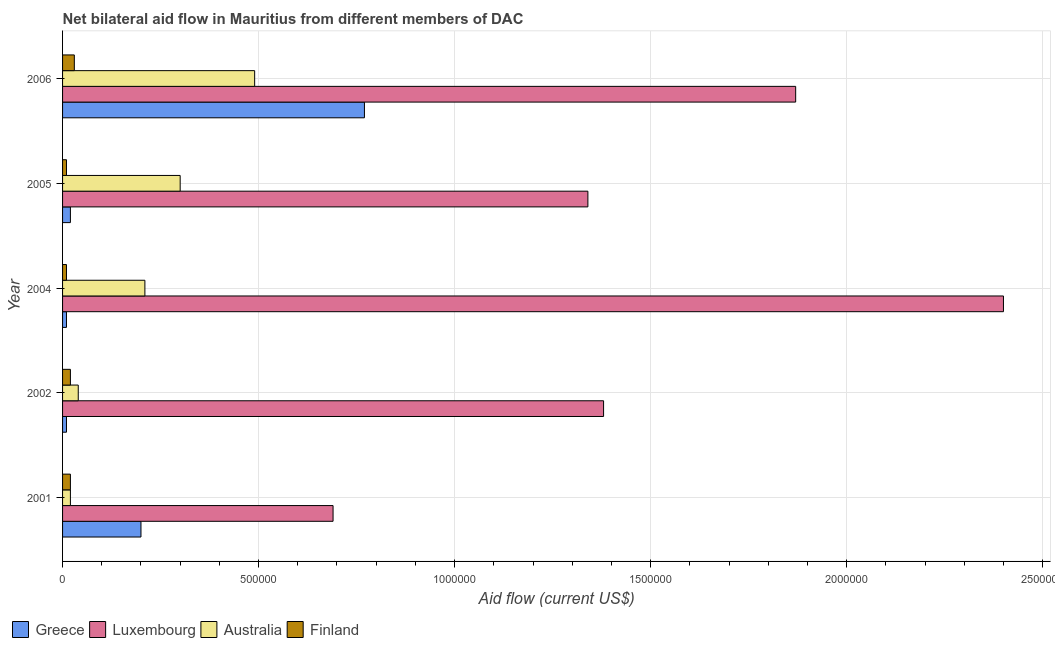Are the number of bars per tick equal to the number of legend labels?
Make the answer very short. Yes. Are the number of bars on each tick of the Y-axis equal?
Make the answer very short. Yes. What is the label of the 5th group of bars from the top?
Keep it short and to the point. 2001. What is the amount of aid given by australia in 2006?
Keep it short and to the point. 4.90e+05. Across all years, what is the maximum amount of aid given by australia?
Your answer should be very brief. 4.90e+05. Across all years, what is the minimum amount of aid given by finland?
Your answer should be very brief. 10000. In which year was the amount of aid given by australia maximum?
Your answer should be very brief. 2006. What is the total amount of aid given by finland in the graph?
Your response must be concise. 9.00e+04. What is the difference between the amount of aid given by greece in 2004 and that in 2005?
Provide a succinct answer. -10000. What is the difference between the amount of aid given by greece in 2005 and the amount of aid given by australia in 2001?
Provide a succinct answer. 0. What is the average amount of aid given by greece per year?
Provide a short and direct response. 2.02e+05. In the year 2005, what is the difference between the amount of aid given by greece and amount of aid given by australia?
Ensure brevity in your answer.  -2.80e+05. In how many years, is the amount of aid given by greece greater than 1500000 US$?
Make the answer very short. 0. Is the difference between the amount of aid given by finland in 2002 and 2006 greater than the difference between the amount of aid given by greece in 2002 and 2006?
Ensure brevity in your answer.  Yes. What is the difference between the highest and the second highest amount of aid given by greece?
Offer a terse response. 5.70e+05. What is the difference between the highest and the lowest amount of aid given by greece?
Give a very brief answer. 7.60e+05. In how many years, is the amount of aid given by finland greater than the average amount of aid given by finland taken over all years?
Keep it short and to the point. 3. What does the 1st bar from the bottom in 2002 represents?
Give a very brief answer. Greece. How many years are there in the graph?
Keep it short and to the point. 5. What is the difference between two consecutive major ticks on the X-axis?
Offer a very short reply. 5.00e+05. Are the values on the major ticks of X-axis written in scientific E-notation?
Your response must be concise. No. How are the legend labels stacked?
Keep it short and to the point. Horizontal. What is the title of the graph?
Provide a short and direct response. Net bilateral aid flow in Mauritius from different members of DAC. Does "Tracking ability" appear as one of the legend labels in the graph?
Provide a short and direct response. No. What is the label or title of the Y-axis?
Provide a succinct answer. Year. What is the Aid flow (current US$) in Luxembourg in 2001?
Make the answer very short. 6.90e+05. What is the Aid flow (current US$) of Australia in 2001?
Your response must be concise. 2.00e+04. What is the Aid flow (current US$) of Greece in 2002?
Provide a succinct answer. 10000. What is the Aid flow (current US$) of Luxembourg in 2002?
Offer a terse response. 1.38e+06. What is the Aid flow (current US$) in Australia in 2002?
Keep it short and to the point. 4.00e+04. What is the Aid flow (current US$) in Finland in 2002?
Offer a very short reply. 2.00e+04. What is the Aid flow (current US$) in Greece in 2004?
Your answer should be compact. 10000. What is the Aid flow (current US$) of Luxembourg in 2004?
Offer a very short reply. 2.40e+06. What is the Aid flow (current US$) of Finland in 2004?
Provide a short and direct response. 10000. What is the Aid flow (current US$) in Luxembourg in 2005?
Offer a terse response. 1.34e+06. What is the Aid flow (current US$) in Greece in 2006?
Provide a short and direct response. 7.70e+05. What is the Aid flow (current US$) of Luxembourg in 2006?
Provide a short and direct response. 1.87e+06. What is the Aid flow (current US$) in Australia in 2006?
Keep it short and to the point. 4.90e+05. Across all years, what is the maximum Aid flow (current US$) in Greece?
Your answer should be compact. 7.70e+05. Across all years, what is the maximum Aid flow (current US$) of Luxembourg?
Your answer should be very brief. 2.40e+06. Across all years, what is the maximum Aid flow (current US$) of Australia?
Provide a short and direct response. 4.90e+05. Across all years, what is the minimum Aid flow (current US$) of Greece?
Make the answer very short. 10000. Across all years, what is the minimum Aid flow (current US$) of Luxembourg?
Give a very brief answer. 6.90e+05. What is the total Aid flow (current US$) of Greece in the graph?
Make the answer very short. 1.01e+06. What is the total Aid flow (current US$) of Luxembourg in the graph?
Make the answer very short. 7.68e+06. What is the total Aid flow (current US$) in Australia in the graph?
Make the answer very short. 1.06e+06. What is the total Aid flow (current US$) of Finland in the graph?
Make the answer very short. 9.00e+04. What is the difference between the Aid flow (current US$) of Luxembourg in 2001 and that in 2002?
Keep it short and to the point. -6.90e+05. What is the difference between the Aid flow (current US$) of Luxembourg in 2001 and that in 2004?
Your response must be concise. -1.71e+06. What is the difference between the Aid flow (current US$) in Australia in 2001 and that in 2004?
Your answer should be very brief. -1.90e+05. What is the difference between the Aid flow (current US$) in Greece in 2001 and that in 2005?
Ensure brevity in your answer.  1.80e+05. What is the difference between the Aid flow (current US$) in Luxembourg in 2001 and that in 2005?
Make the answer very short. -6.50e+05. What is the difference between the Aid flow (current US$) of Australia in 2001 and that in 2005?
Keep it short and to the point. -2.80e+05. What is the difference between the Aid flow (current US$) in Finland in 2001 and that in 2005?
Your answer should be compact. 10000. What is the difference between the Aid flow (current US$) of Greece in 2001 and that in 2006?
Offer a terse response. -5.70e+05. What is the difference between the Aid flow (current US$) in Luxembourg in 2001 and that in 2006?
Provide a short and direct response. -1.18e+06. What is the difference between the Aid flow (current US$) in Australia in 2001 and that in 2006?
Provide a succinct answer. -4.70e+05. What is the difference between the Aid flow (current US$) in Finland in 2001 and that in 2006?
Your answer should be compact. -10000. What is the difference between the Aid flow (current US$) in Greece in 2002 and that in 2004?
Your answer should be very brief. 0. What is the difference between the Aid flow (current US$) of Luxembourg in 2002 and that in 2004?
Your answer should be very brief. -1.02e+06. What is the difference between the Aid flow (current US$) in Luxembourg in 2002 and that in 2005?
Your answer should be very brief. 4.00e+04. What is the difference between the Aid flow (current US$) of Greece in 2002 and that in 2006?
Your response must be concise. -7.60e+05. What is the difference between the Aid flow (current US$) in Luxembourg in 2002 and that in 2006?
Provide a succinct answer. -4.90e+05. What is the difference between the Aid flow (current US$) in Australia in 2002 and that in 2006?
Your answer should be very brief. -4.50e+05. What is the difference between the Aid flow (current US$) of Greece in 2004 and that in 2005?
Your response must be concise. -10000. What is the difference between the Aid flow (current US$) of Luxembourg in 2004 and that in 2005?
Your response must be concise. 1.06e+06. What is the difference between the Aid flow (current US$) in Australia in 2004 and that in 2005?
Ensure brevity in your answer.  -9.00e+04. What is the difference between the Aid flow (current US$) of Greece in 2004 and that in 2006?
Your answer should be very brief. -7.60e+05. What is the difference between the Aid flow (current US$) of Luxembourg in 2004 and that in 2006?
Your answer should be compact. 5.30e+05. What is the difference between the Aid flow (current US$) of Australia in 2004 and that in 2006?
Keep it short and to the point. -2.80e+05. What is the difference between the Aid flow (current US$) in Greece in 2005 and that in 2006?
Ensure brevity in your answer.  -7.50e+05. What is the difference between the Aid flow (current US$) in Luxembourg in 2005 and that in 2006?
Your answer should be very brief. -5.30e+05. What is the difference between the Aid flow (current US$) of Greece in 2001 and the Aid flow (current US$) of Luxembourg in 2002?
Keep it short and to the point. -1.18e+06. What is the difference between the Aid flow (current US$) in Greece in 2001 and the Aid flow (current US$) in Australia in 2002?
Give a very brief answer. 1.60e+05. What is the difference between the Aid flow (current US$) in Greece in 2001 and the Aid flow (current US$) in Finland in 2002?
Your response must be concise. 1.80e+05. What is the difference between the Aid flow (current US$) in Luxembourg in 2001 and the Aid flow (current US$) in Australia in 2002?
Your answer should be very brief. 6.50e+05. What is the difference between the Aid flow (current US$) in Luxembourg in 2001 and the Aid flow (current US$) in Finland in 2002?
Offer a very short reply. 6.70e+05. What is the difference between the Aid flow (current US$) of Greece in 2001 and the Aid flow (current US$) of Luxembourg in 2004?
Your answer should be compact. -2.20e+06. What is the difference between the Aid flow (current US$) in Greece in 2001 and the Aid flow (current US$) in Australia in 2004?
Your answer should be very brief. -10000. What is the difference between the Aid flow (current US$) of Greece in 2001 and the Aid flow (current US$) of Finland in 2004?
Give a very brief answer. 1.90e+05. What is the difference between the Aid flow (current US$) in Luxembourg in 2001 and the Aid flow (current US$) in Finland in 2004?
Offer a very short reply. 6.80e+05. What is the difference between the Aid flow (current US$) of Greece in 2001 and the Aid flow (current US$) of Luxembourg in 2005?
Your response must be concise. -1.14e+06. What is the difference between the Aid flow (current US$) in Luxembourg in 2001 and the Aid flow (current US$) in Finland in 2005?
Your answer should be very brief. 6.80e+05. What is the difference between the Aid flow (current US$) in Greece in 2001 and the Aid flow (current US$) in Luxembourg in 2006?
Provide a succinct answer. -1.67e+06. What is the difference between the Aid flow (current US$) in Greece in 2001 and the Aid flow (current US$) in Finland in 2006?
Your response must be concise. 1.70e+05. What is the difference between the Aid flow (current US$) in Luxembourg in 2001 and the Aid flow (current US$) in Australia in 2006?
Your answer should be compact. 2.00e+05. What is the difference between the Aid flow (current US$) in Luxembourg in 2001 and the Aid flow (current US$) in Finland in 2006?
Make the answer very short. 6.60e+05. What is the difference between the Aid flow (current US$) of Australia in 2001 and the Aid flow (current US$) of Finland in 2006?
Provide a short and direct response. -10000. What is the difference between the Aid flow (current US$) in Greece in 2002 and the Aid flow (current US$) in Luxembourg in 2004?
Make the answer very short. -2.39e+06. What is the difference between the Aid flow (current US$) in Greece in 2002 and the Aid flow (current US$) in Australia in 2004?
Keep it short and to the point. -2.00e+05. What is the difference between the Aid flow (current US$) of Luxembourg in 2002 and the Aid flow (current US$) of Australia in 2004?
Provide a succinct answer. 1.17e+06. What is the difference between the Aid flow (current US$) in Luxembourg in 2002 and the Aid flow (current US$) in Finland in 2004?
Offer a very short reply. 1.37e+06. What is the difference between the Aid flow (current US$) in Australia in 2002 and the Aid flow (current US$) in Finland in 2004?
Your answer should be very brief. 3.00e+04. What is the difference between the Aid flow (current US$) in Greece in 2002 and the Aid flow (current US$) in Luxembourg in 2005?
Offer a very short reply. -1.33e+06. What is the difference between the Aid flow (current US$) in Greece in 2002 and the Aid flow (current US$) in Australia in 2005?
Make the answer very short. -2.90e+05. What is the difference between the Aid flow (current US$) in Luxembourg in 2002 and the Aid flow (current US$) in Australia in 2005?
Make the answer very short. 1.08e+06. What is the difference between the Aid flow (current US$) in Luxembourg in 2002 and the Aid flow (current US$) in Finland in 2005?
Provide a short and direct response. 1.37e+06. What is the difference between the Aid flow (current US$) of Greece in 2002 and the Aid flow (current US$) of Luxembourg in 2006?
Offer a terse response. -1.86e+06. What is the difference between the Aid flow (current US$) of Greece in 2002 and the Aid flow (current US$) of Australia in 2006?
Your response must be concise. -4.80e+05. What is the difference between the Aid flow (current US$) in Luxembourg in 2002 and the Aid flow (current US$) in Australia in 2006?
Your answer should be very brief. 8.90e+05. What is the difference between the Aid flow (current US$) of Luxembourg in 2002 and the Aid flow (current US$) of Finland in 2006?
Provide a succinct answer. 1.35e+06. What is the difference between the Aid flow (current US$) of Greece in 2004 and the Aid flow (current US$) of Luxembourg in 2005?
Provide a short and direct response. -1.33e+06. What is the difference between the Aid flow (current US$) of Greece in 2004 and the Aid flow (current US$) of Australia in 2005?
Your answer should be very brief. -2.90e+05. What is the difference between the Aid flow (current US$) of Greece in 2004 and the Aid flow (current US$) of Finland in 2005?
Ensure brevity in your answer.  0. What is the difference between the Aid flow (current US$) of Luxembourg in 2004 and the Aid flow (current US$) of Australia in 2005?
Keep it short and to the point. 2.10e+06. What is the difference between the Aid flow (current US$) in Luxembourg in 2004 and the Aid flow (current US$) in Finland in 2005?
Your response must be concise. 2.39e+06. What is the difference between the Aid flow (current US$) in Australia in 2004 and the Aid flow (current US$) in Finland in 2005?
Ensure brevity in your answer.  2.00e+05. What is the difference between the Aid flow (current US$) of Greece in 2004 and the Aid flow (current US$) of Luxembourg in 2006?
Provide a succinct answer. -1.86e+06. What is the difference between the Aid flow (current US$) in Greece in 2004 and the Aid flow (current US$) in Australia in 2006?
Make the answer very short. -4.80e+05. What is the difference between the Aid flow (current US$) of Greece in 2004 and the Aid flow (current US$) of Finland in 2006?
Make the answer very short. -2.00e+04. What is the difference between the Aid flow (current US$) of Luxembourg in 2004 and the Aid flow (current US$) of Australia in 2006?
Make the answer very short. 1.91e+06. What is the difference between the Aid flow (current US$) of Luxembourg in 2004 and the Aid flow (current US$) of Finland in 2006?
Your answer should be very brief. 2.37e+06. What is the difference between the Aid flow (current US$) of Australia in 2004 and the Aid flow (current US$) of Finland in 2006?
Give a very brief answer. 1.80e+05. What is the difference between the Aid flow (current US$) in Greece in 2005 and the Aid flow (current US$) in Luxembourg in 2006?
Give a very brief answer. -1.85e+06. What is the difference between the Aid flow (current US$) in Greece in 2005 and the Aid flow (current US$) in Australia in 2006?
Ensure brevity in your answer.  -4.70e+05. What is the difference between the Aid flow (current US$) of Luxembourg in 2005 and the Aid flow (current US$) of Australia in 2006?
Give a very brief answer. 8.50e+05. What is the difference between the Aid flow (current US$) of Luxembourg in 2005 and the Aid flow (current US$) of Finland in 2006?
Your response must be concise. 1.31e+06. What is the average Aid flow (current US$) of Greece per year?
Keep it short and to the point. 2.02e+05. What is the average Aid flow (current US$) of Luxembourg per year?
Your response must be concise. 1.54e+06. What is the average Aid flow (current US$) in Australia per year?
Ensure brevity in your answer.  2.12e+05. What is the average Aid flow (current US$) in Finland per year?
Provide a short and direct response. 1.80e+04. In the year 2001, what is the difference between the Aid flow (current US$) in Greece and Aid flow (current US$) in Luxembourg?
Offer a very short reply. -4.90e+05. In the year 2001, what is the difference between the Aid flow (current US$) in Greece and Aid flow (current US$) in Finland?
Your response must be concise. 1.80e+05. In the year 2001, what is the difference between the Aid flow (current US$) of Luxembourg and Aid flow (current US$) of Australia?
Make the answer very short. 6.70e+05. In the year 2001, what is the difference between the Aid flow (current US$) of Luxembourg and Aid flow (current US$) of Finland?
Make the answer very short. 6.70e+05. In the year 2001, what is the difference between the Aid flow (current US$) in Australia and Aid flow (current US$) in Finland?
Your response must be concise. 0. In the year 2002, what is the difference between the Aid flow (current US$) in Greece and Aid flow (current US$) in Luxembourg?
Provide a short and direct response. -1.37e+06. In the year 2002, what is the difference between the Aid flow (current US$) of Greece and Aid flow (current US$) of Australia?
Offer a very short reply. -3.00e+04. In the year 2002, what is the difference between the Aid flow (current US$) of Luxembourg and Aid flow (current US$) of Australia?
Provide a short and direct response. 1.34e+06. In the year 2002, what is the difference between the Aid flow (current US$) in Luxembourg and Aid flow (current US$) in Finland?
Offer a terse response. 1.36e+06. In the year 2004, what is the difference between the Aid flow (current US$) of Greece and Aid flow (current US$) of Luxembourg?
Keep it short and to the point. -2.39e+06. In the year 2004, what is the difference between the Aid flow (current US$) in Greece and Aid flow (current US$) in Finland?
Give a very brief answer. 0. In the year 2004, what is the difference between the Aid flow (current US$) in Luxembourg and Aid flow (current US$) in Australia?
Provide a short and direct response. 2.19e+06. In the year 2004, what is the difference between the Aid flow (current US$) of Luxembourg and Aid flow (current US$) of Finland?
Your answer should be compact. 2.39e+06. In the year 2004, what is the difference between the Aid flow (current US$) in Australia and Aid flow (current US$) in Finland?
Your answer should be very brief. 2.00e+05. In the year 2005, what is the difference between the Aid flow (current US$) of Greece and Aid flow (current US$) of Luxembourg?
Make the answer very short. -1.32e+06. In the year 2005, what is the difference between the Aid flow (current US$) in Greece and Aid flow (current US$) in Australia?
Offer a terse response. -2.80e+05. In the year 2005, what is the difference between the Aid flow (current US$) of Greece and Aid flow (current US$) of Finland?
Keep it short and to the point. 10000. In the year 2005, what is the difference between the Aid flow (current US$) of Luxembourg and Aid flow (current US$) of Australia?
Your response must be concise. 1.04e+06. In the year 2005, what is the difference between the Aid flow (current US$) of Luxembourg and Aid flow (current US$) of Finland?
Your answer should be compact. 1.33e+06. In the year 2006, what is the difference between the Aid flow (current US$) in Greece and Aid flow (current US$) in Luxembourg?
Give a very brief answer. -1.10e+06. In the year 2006, what is the difference between the Aid flow (current US$) in Greece and Aid flow (current US$) in Finland?
Provide a succinct answer. 7.40e+05. In the year 2006, what is the difference between the Aid flow (current US$) in Luxembourg and Aid flow (current US$) in Australia?
Give a very brief answer. 1.38e+06. In the year 2006, what is the difference between the Aid flow (current US$) in Luxembourg and Aid flow (current US$) in Finland?
Give a very brief answer. 1.84e+06. In the year 2006, what is the difference between the Aid flow (current US$) in Australia and Aid flow (current US$) in Finland?
Ensure brevity in your answer.  4.60e+05. What is the ratio of the Aid flow (current US$) in Finland in 2001 to that in 2002?
Offer a very short reply. 1. What is the ratio of the Aid flow (current US$) of Luxembourg in 2001 to that in 2004?
Offer a terse response. 0.29. What is the ratio of the Aid flow (current US$) of Australia in 2001 to that in 2004?
Your answer should be very brief. 0.1. What is the ratio of the Aid flow (current US$) in Luxembourg in 2001 to that in 2005?
Make the answer very short. 0.51. What is the ratio of the Aid flow (current US$) of Australia in 2001 to that in 2005?
Offer a very short reply. 0.07. What is the ratio of the Aid flow (current US$) of Finland in 2001 to that in 2005?
Your response must be concise. 2. What is the ratio of the Aid flow (current US$) of Greece in 2001 to that in 2006?
Provide a short and direct response. 0.26. What is the ratio of the Aid flow (current US$) in Luxembourg in 2001 to that in 2006?
Offer a very short reply. 0.37. What is the ratio of the Aid flow (current US$) of Australia in 2001 to that in 2006?
Your answer should be compact. 0.04. What is the ratio of the Aid flow (current US$) in Finland in 2001 to that in 2006?
Your response must be concise. 0.67. What is the ratio of the Aid flow (current US$) in Greece in 2002 to that in 2004?
Your response must be concise. 1. What is the ratio of the Aid flow (current US$) in Luxembourg in 2002 to that in 2004?
Your answer should be very brief. 0.57. What is the ratio of the Aid flow (current US$) in Australia in 2002 to that in 2004?
Provide a succinct answer. 0.19. What is the ratio of the Aid flow (current US$) of Greece in 2002 to that in 2005?
Offer a terse response. 0.5. What is the ratio of the Aid flow (current US$) of Luxembourg in 2002 to that in 2005?
Make the answer very short. 1.03. What is the ratio of the Aid flow (current US$) of Australia in 2002 to that in 2005?
Ensure brevity in your answer.  0.13. What is the ratio of the Aid flow (current US$) in Finland in 2002 to that in 2005?
Give a very brief answer. 2. What is the ratio of the Aid flow (current US$) in Greece in 2002 to that in 2006?
Keep it short and to the point. 0.01. What is the ratio of the Aid flow (current US$) in Luxembourg in 2002 to that in 2006?
Give a very brief answer. 0.74. What is the ratio of the Aid flow (current US$) in Australia in 2002 to that in 2006?
Your answer should be compact. 0.08. What is the ratio of the Aid flow (current US$) of Finland in 2002 to that in 2006?
Keep it short and to the point. 0.67. What is the ratio of the Aid flow (current US$) of Luxembourg in 2004 to that in 2005?
Provide a short and direct response. 1.79. What is the ratio of the Aid flow (current US$) of Finland in 2004 to that in 2005?
Offer a very short reply. 1. What is the ratio of the Aid flow (current US$) of Greece in 2004 to that in 2006?
Your answer should be very brief. 0.01. What is the ratio of the Aid flow (current US$) in Luxembourg in 2004 to that in 2006?
Offer a very short reply. 1.28. What is the ratio of the Aid flow (current US$) in Australia in 2004 to that in 2006?
Make the answer very short. 0.43. What is the ratio of the Aid flow (current US$) in Greece in 2005 to that in 2006?
Ensure brevity in your answer.  0.03. What is the ratio of the Aid flow (current US$) in Luxembourg in 2005 to that in 2006?
Offer a terse response. 0.72. What is the ratio of the Aid flow (current US$) of Australia in 2005 to that in 2006?
Provide a succinct answer. 0.61. What is the difference between the highest and the second highest Aid flow (current US$) of Greece?
Your response must be concise. 5.70e+05. What is the difference between the highest and the second highest Aid flow (current US$) in Luxembourg?
Offer a very short reply. 5.30e+05. What is the difference between the highest and the second highest Aid flow (current US$) in Australia?
Your answer should be very brief. 1.90e+05. What is the difference between the highest and the lowest Aid flow (current US$) of Greece?
Make the answer very short. 7.60e+05. What is the difference between the highest and the lowest Aid flow (current US$) of Luxembourg?
Your answer should be very brief. 1.71e+06. What is the difference between the highest and the lowest Aid flow (current US$) in Australia?
Ensure brevity in your answer.  4.70e+05. What is the difference between the highest and the lowest Aid flow (current US$) of Finland?
Give a very brief answer. 2.00e+04. 